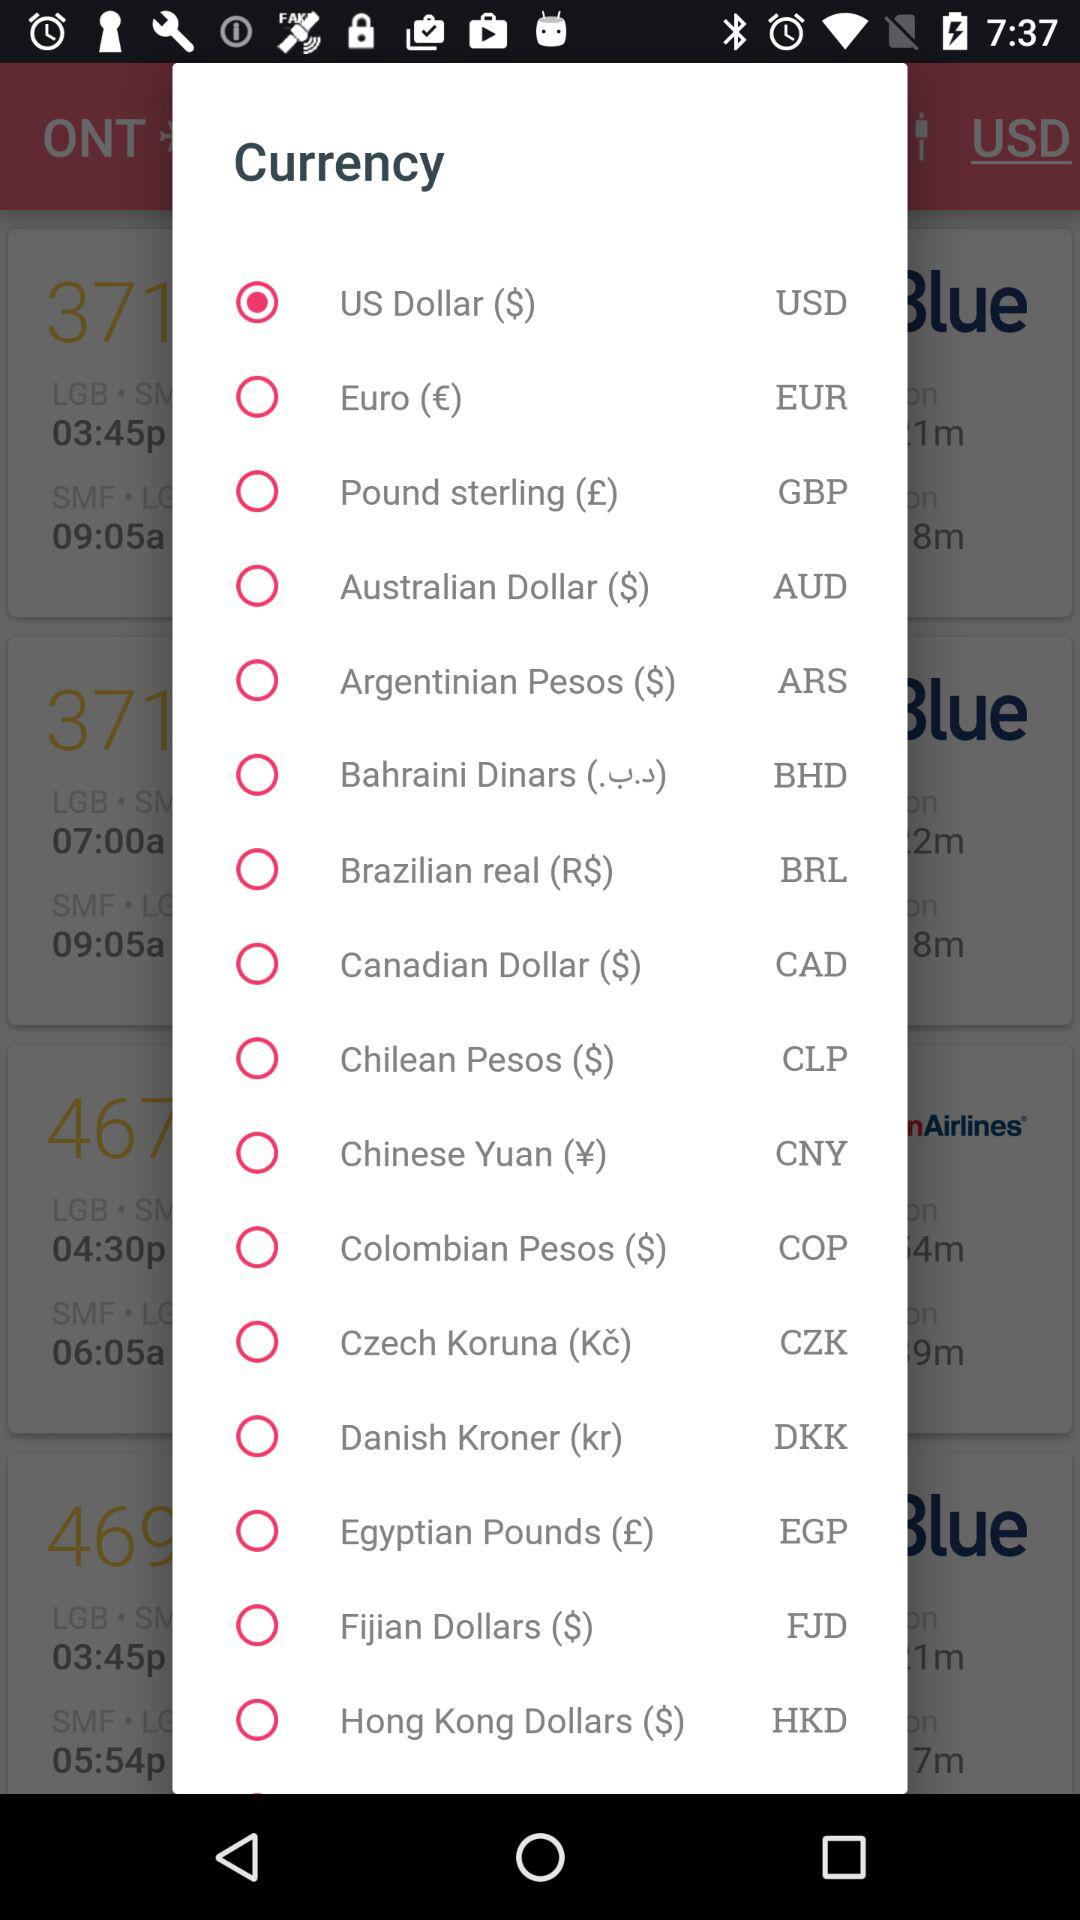What is the abbreviation of the Canadian dollar? The abbreviation is CAD. 